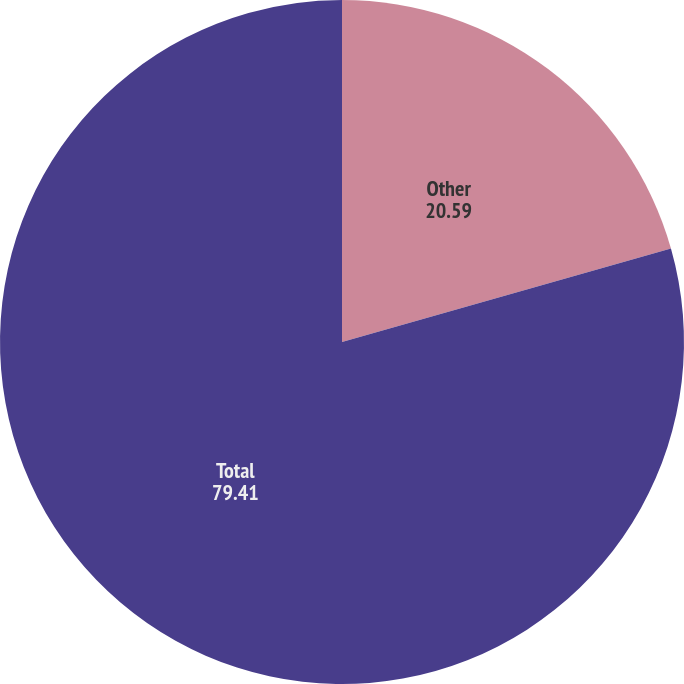Convert chart to OTSL. <chart><loc_0><loc_0><loc_500><loc_500><pie_chart><fcel>Other<fcel>Total<nl><fcel>20.59%<fcel>79.41%<nl></chart> 